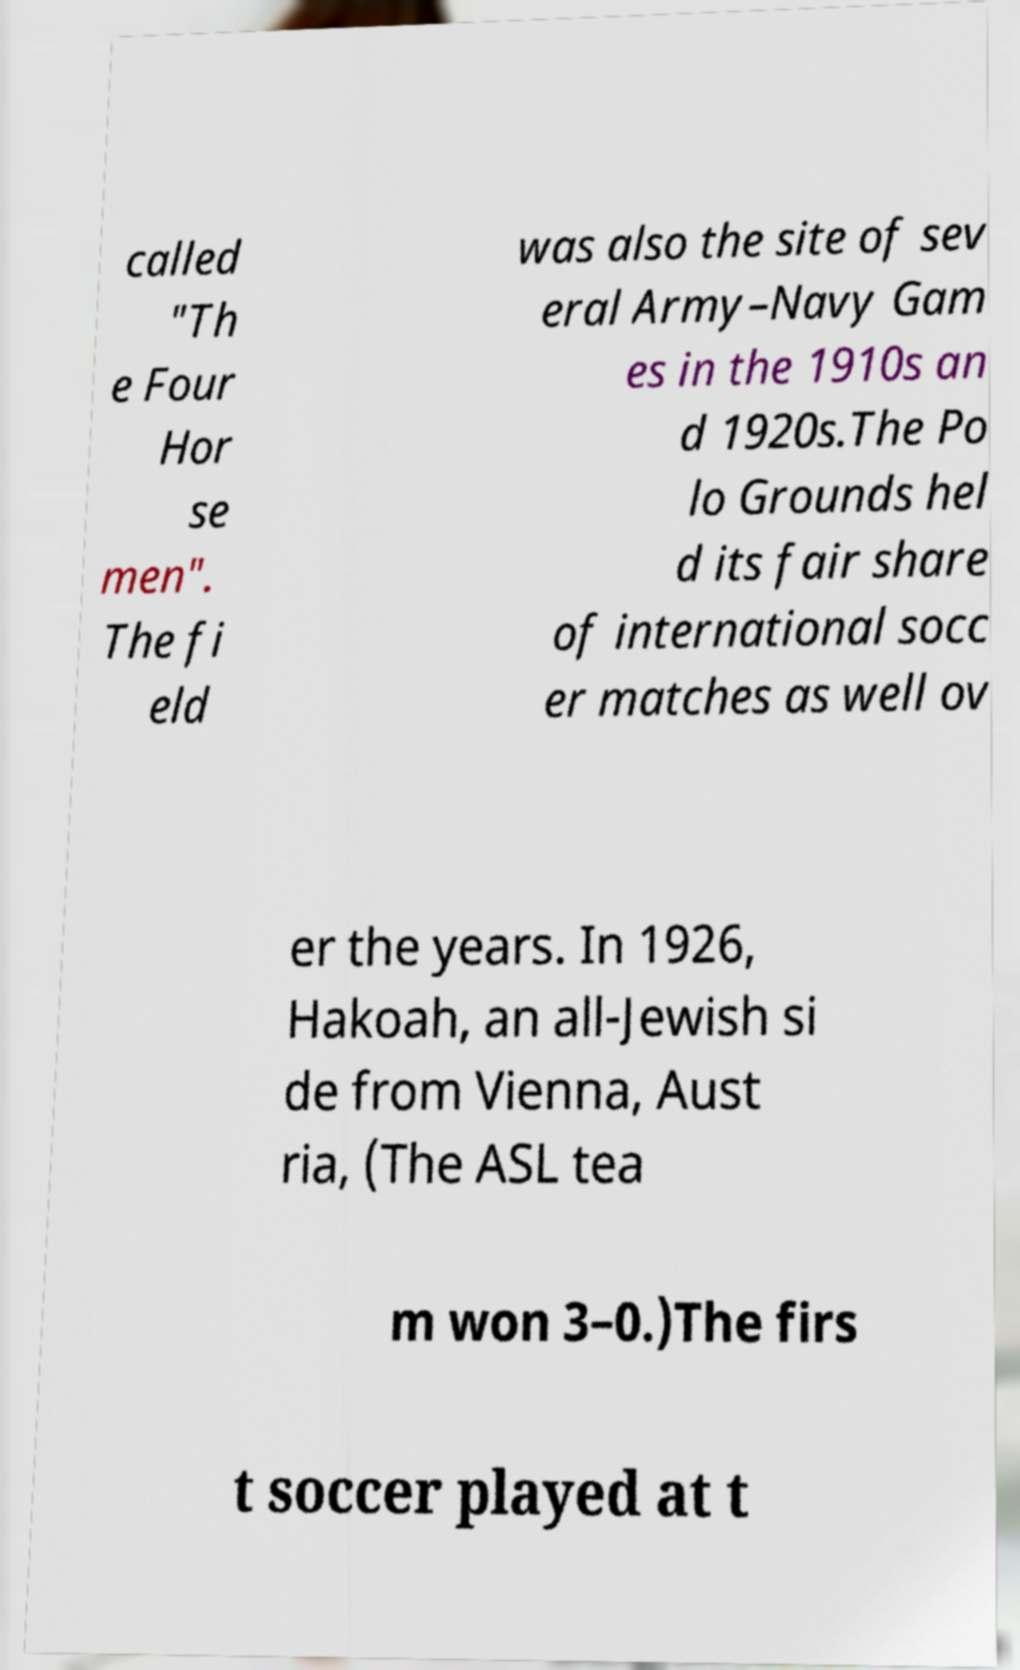I need the written content from this picture converted into text. Can you do that? The text in the image is a snippet about historical events held at Polo Grounds. It mentions 'The Four Horsemen', and several Army-Navy Games during the 1910s and 1920s. Polo Grounds also hosted significant international soccer matches. In 1926, Hakoah, an all-Jewish side from Vienna, Austria, played there, with the ASL team winning 3-0. The text seems to cut off and might discuss the first instance of soccer played at the venue. 